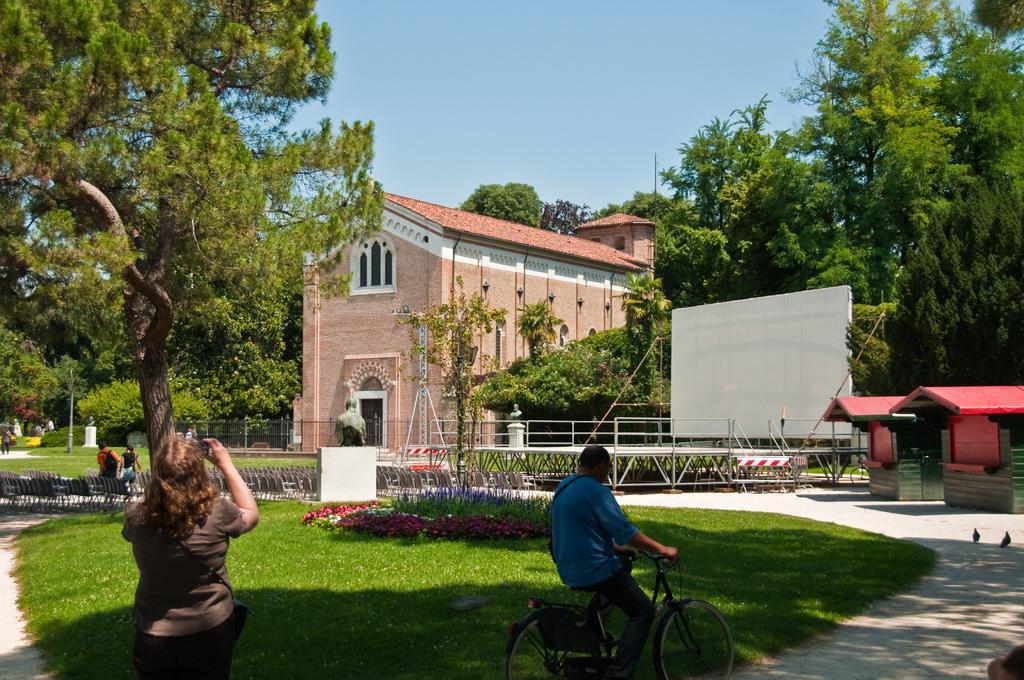Please provide a concise description of this image. This is a picture consist of a house , in front of a house there are some trees and there is a sky visible in the back ground , in front there is a person wearing a blue color shirt riding on the bi-cycle ,there is a grass visible and there is a woman on left side wearing a gray color t-shirt ,she is standing on the grass and there are some chairs kept on the road and there is a sculpture seen on the middle and there is a white color board visible on the right side and there are two persons walking on the road. And there are two birds seen on the right side. 